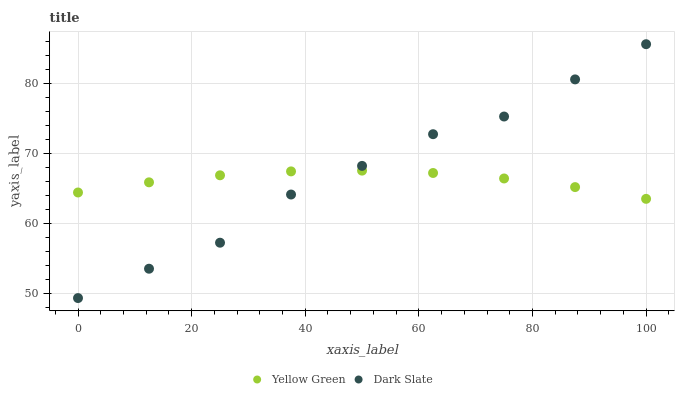Does Yellow Green have the minimum area under the curve?
Answer yes or no. Yes. Does Dark Slate have the maximum area under the curve?
Answer yes or no. Yes. Does Yellow Green have the maximum area under the curve?
Answer yes or no. No. Is Yellow Green the smoothest?
Answer yes or no. Yes. Is Dark Slate the roughest?
Answer yes or no. Yes. Is Yellow Green the roughest?
Answer yes or no. No. Does Dark Slate have the lowest value?
Answer yes or no. Yes. Does Yellow Green have the lowest value?
Answer yes or no. No. Does Dark Slate have the highest value?
Answer yes or no. Yes. Does Yellow Green have the highest value?
Answer yes or no. No. Does Dark Slate intersect Yellow Green?
Answer yes or no. Yes. Is Dark Slate less than Yellow Green?
Answer yes or no. No. Is Dark Slate greater than Yellow Green?
Answer yes or no. No. 